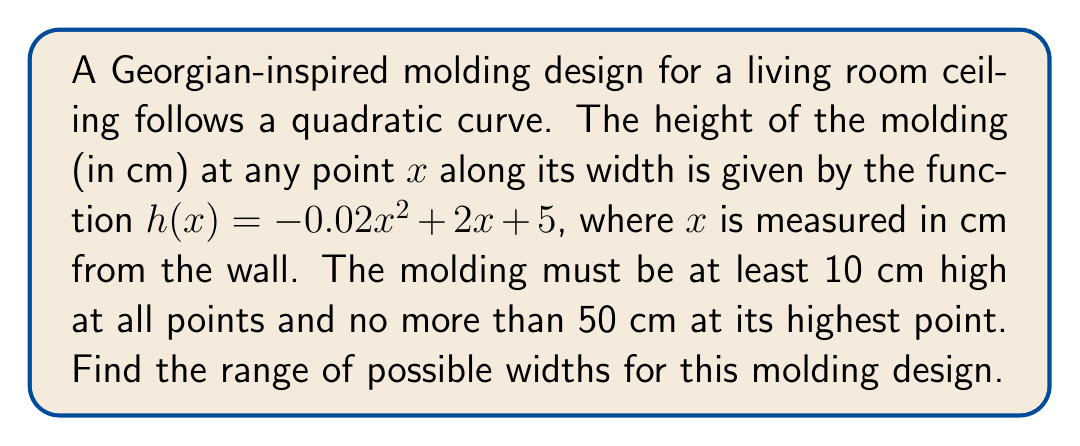Solve this math problem. 1) First, we need to find the maximum height of the molding. This occurs at the vertex of the parabola.

   To find the x-coordinate of the vertex: $x = -\frac{b}{2a} = -\frac{2}{2(-0.02)} = 50$ cm

   The maximum height is: $h(50) = -0.02(50)^2 + 2(50) + 5 = 55$ cm

2) Since the maximum height cannot exceed 50 cm, we need to solve:

   $-0.02x^2 + 2x + 5 \leq 50$

3) Rearranging the inequality:

   $-0.02x^2 + 2x - 45 \leq 0$

4) Solving this quadratic inequality:

   $a = -0.02$, $b = 2$, $c = -45$

   Discriminant: $\Delta = b^2 - 4ac = 2^2 - 4(-0.02)(-45) = 4 - 3.6 = 0.4$

   Roots: $x = \frac{-b \pm \sqrt{\Delta}}{2a}$

   $x_1 = \frac{-2 + \sqrt{0.4}}{-0.04} \approx 96.91$ cm
   $x_2 = \frac{-2 - \sqrt{0.4}}{-0.04} \approx 3.09$ cm

5) For the minimum height requirement, we solve:

   $-0.02x^2 + 2x + 5 \geq 10$

   $-0.02x^2 + 2x - 5 \geq 0$

   Roots: $x_3 \approx 102.47$ cm, $x_4 \approx -2.47$ cm

6) Combining these results, the width must be between 3.09 cm and 96.91 cm to satisfy both conditions.
Answer: $3.09 \leq x \leq 96.91$ cm 